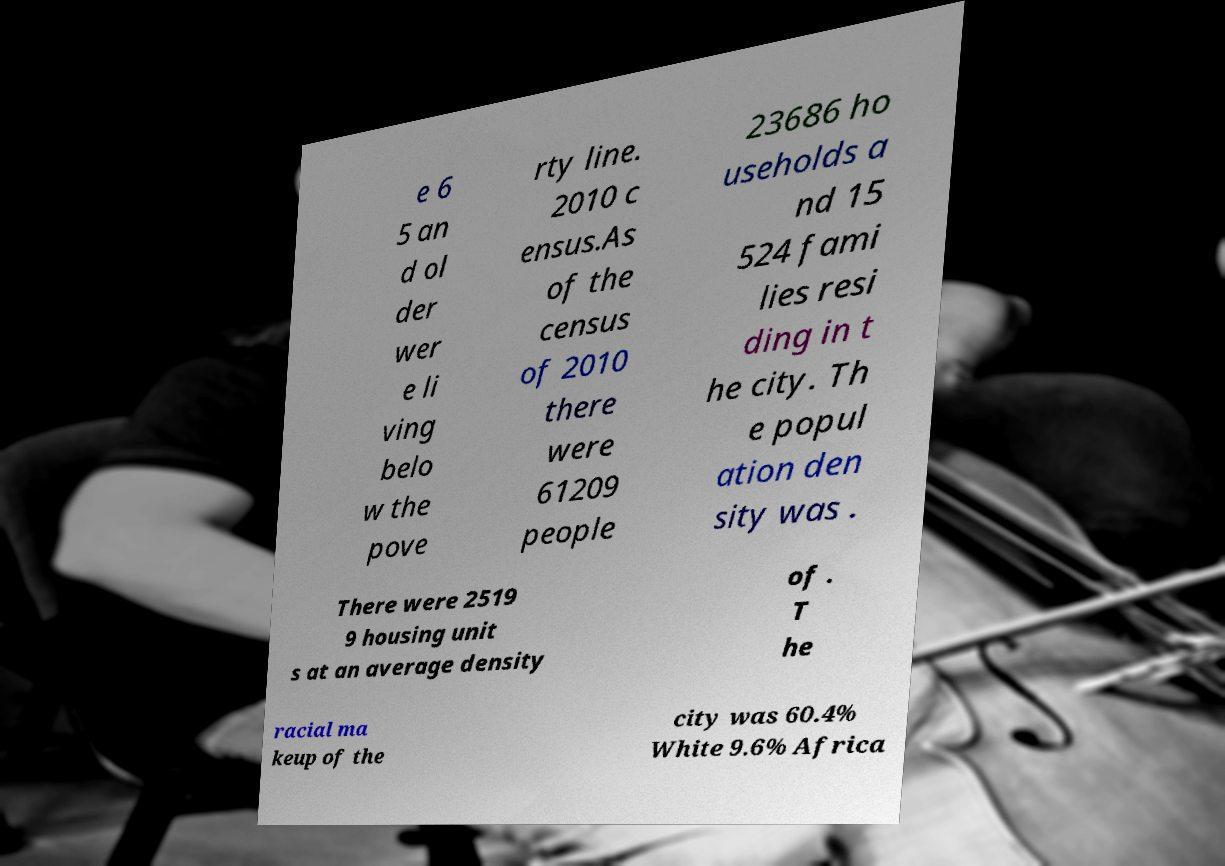Please read and relay the text visible in this image. What does it say? e 6 5 an d ol der wer e li ving belo w the pove rty line. 2010 c ensus.As of the census of 2010 there were 61209 people 23686 ho useholds a nd 15 524 fami lies resi ding in t he city. Th e popul ation den sity was . There were 2519 9 housing unit s at an average density of . T he racial ma keup of the city was 60.4% White 9.6% Africa 